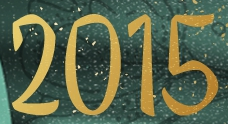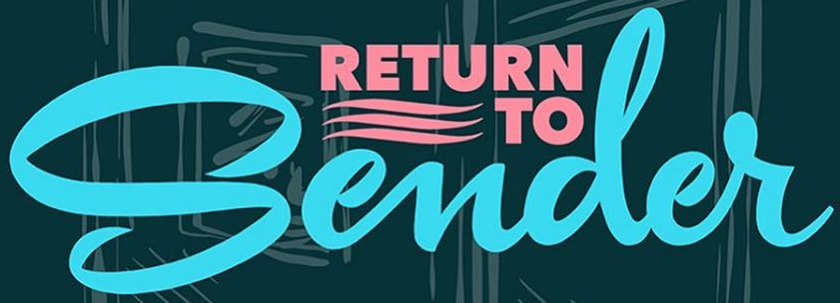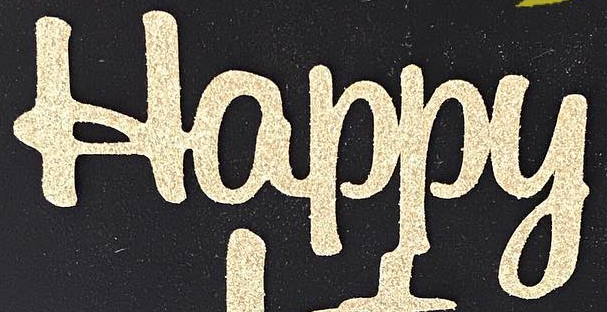Read the text content from these images in order, separated by a semicolon. 2015; Sender; Happy 